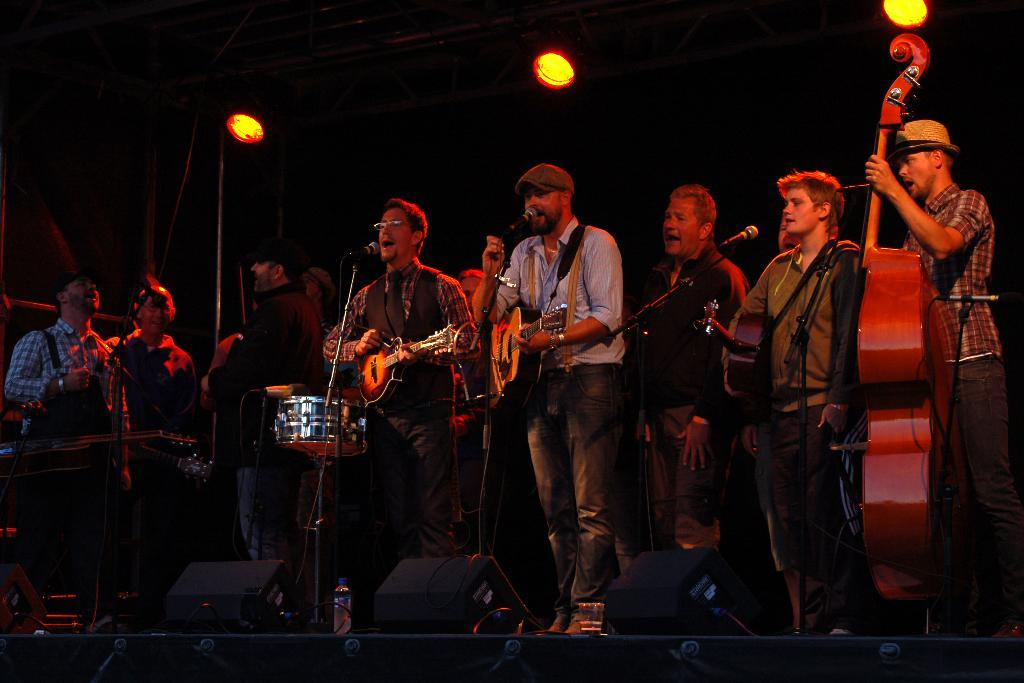What are the people in the image doing? The people in the image are playing musical instruments and singing. What object is present in front of the group? There is a microphone in front of the group. What type of sail can be seen in the image? There is no sail present in the image; it features a group of people playing musical instruments and singing. Who is the judge in the image? There is no judge present in the image. 